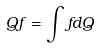<formula> <loc_0><loc_0><loc_500><loc_500>Q f = \int f d Q</formula> 